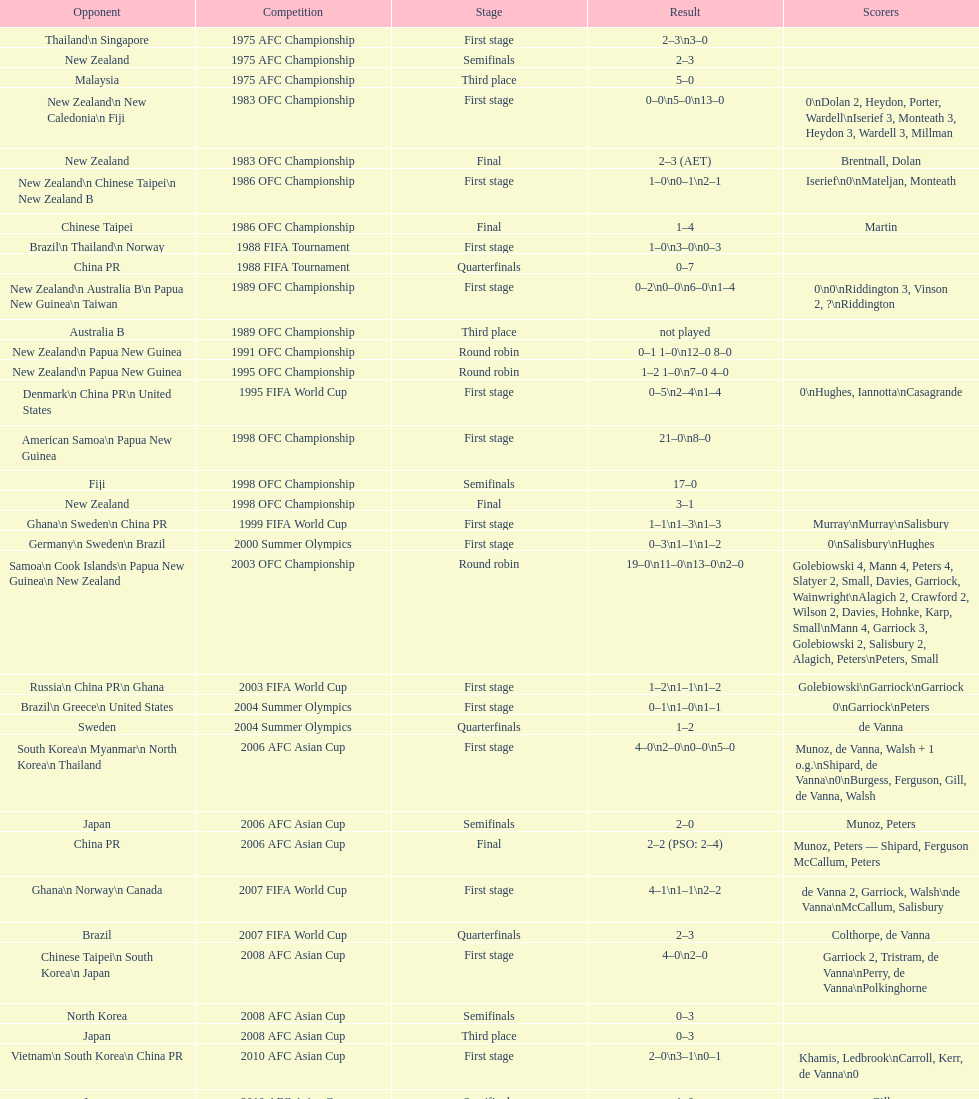How many stages were round robins? 3. 